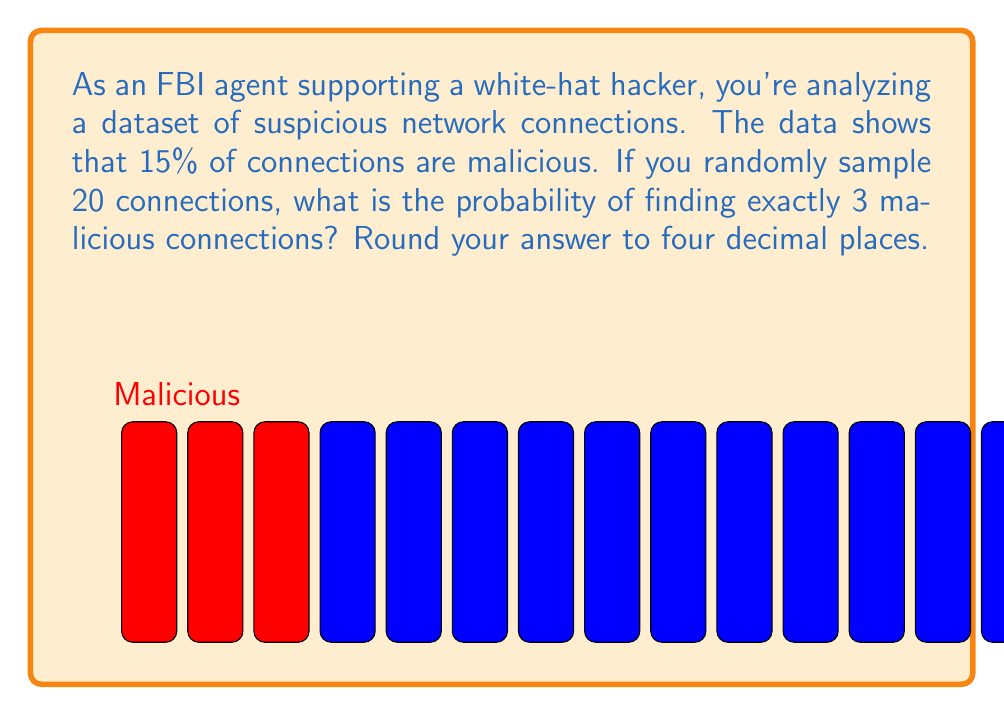Can you answer this question? To solve this problem, we can use the Binomial probability distribution:

1) Let X be the number of malicious connections in a sample of 20.
2) X follows a Binomial distribution with n = 20 (sample size) and p = 0.15 (probability of a malicious connection).

3) We want to find P(X = 3), which is given by the formula:

   $$P(X = k) = \binom{n}{k} p^k (1-p)^{n-k}$$

4) Substituting our values:

   $$P(X = 3) = \binom{20}{3} (0.15)^3 (1-0.15)^{20-3}$$

5) Calculate the binomial coefficient:
   $$\binom{20}{3} = \frac{20!}{3!(20-3)!} = 1140$$

6) Now we can compute:
   $$P(X = 3) = 1140 \cdot (0.15)^3 \cdot (0.85)^{17}$$

7) Using a calculator or computer:
   $$P(X = 3) \approx 1140 \cdot 0.003375 \cdot 0.0434 \approx 0.1669$$

8) Rounding to four decimal places:
   $$P(X = 3) \approx 0.1669$$
Answer: 0.1669 